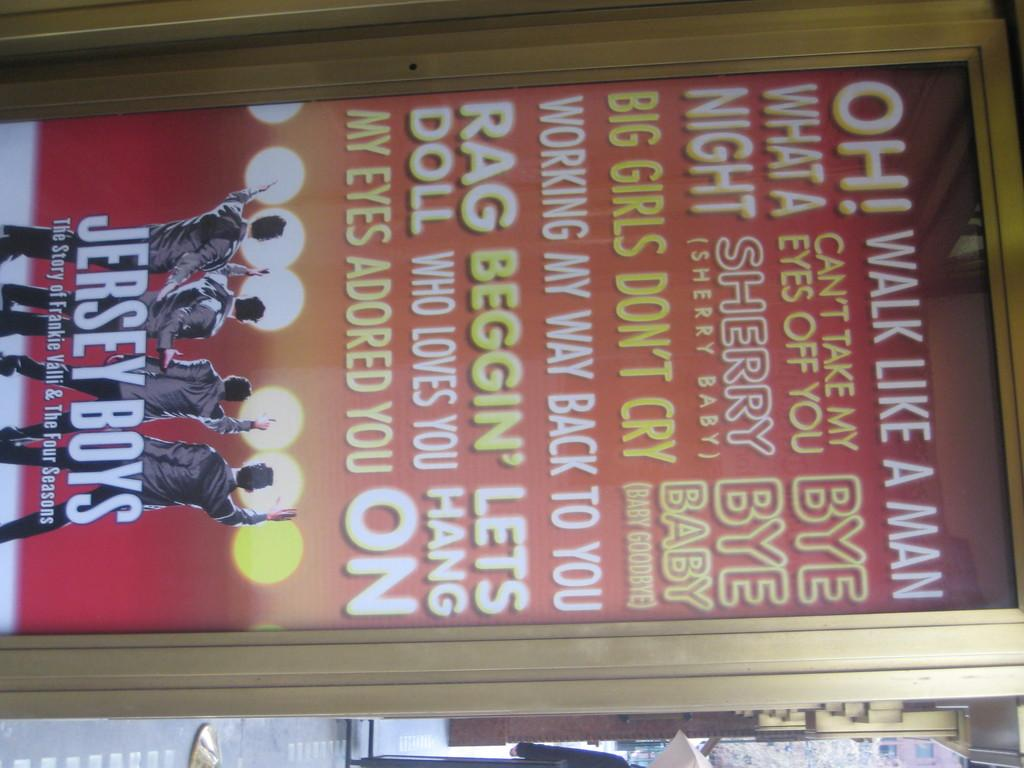<image>
Write a terse but informative summary of the picture. a poster for a show called 'the jersey boys' 